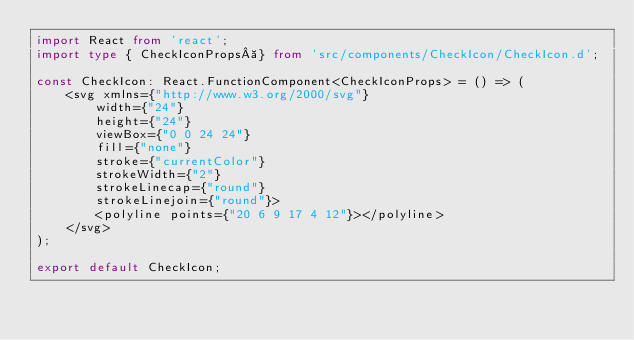Convert code to text. <code><loc_0><loc_0><loc_500><loc_500><_TypeScript_>import React from 'react';
import type { CheckIconProps } from 'src/components/CheckIcon/CheckIcon.d';

const CheckIcon: React.FunctionComponent<CheckIconProps> = () => (
    <svg xmlns={"http://www.w3.org/2000/svg"}
        width={"24"}
        height={"24"}
        viewBox={"0 0 24 24"}
        fill={"none"}
        stroke={"currentColor"}
        strokeWidth={"2"}
        strokeLinecap={"round"}
        strokeLinejoin={"round"}>
        <polyline points={"20 6 9 17 4 12"}></polyline>
    </svg>
);

export default CheckIcon;
</code> 